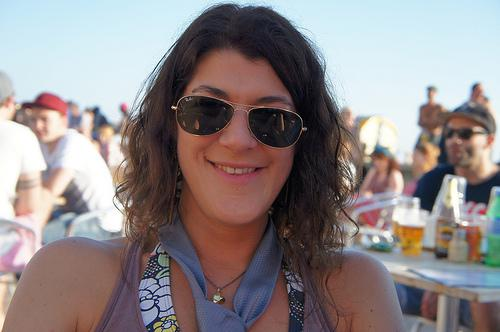Question: when was this photo taken?
Choices:
A. In the morning.
B. During the day.
C. In the evening.
D. At sunrise.
Answer with the letter. Answer: B Question: what color are her sunglasses?
Choices:
A. Yellow.
B. Brass.
C. Silver.
D. Green.
Answer with the letter. Answer: B Question: why is this photo illuminated?
Choices:
A. Candle light.
B. Lamps.
C. Sunlight.
D. Reflected light.
Answer with the letter. Answer: C Question: who is the focus of the photo?
Choices:
A. The man.
B. People.
C. Kids.
D. The woman.
Answer with the letter. Answer: D 